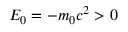<formula> <loc_0><loc_0><loc_500><loc_500>E _ { 0 } = - m _ { 0 } c ^ { 2 } > 0</formula> 